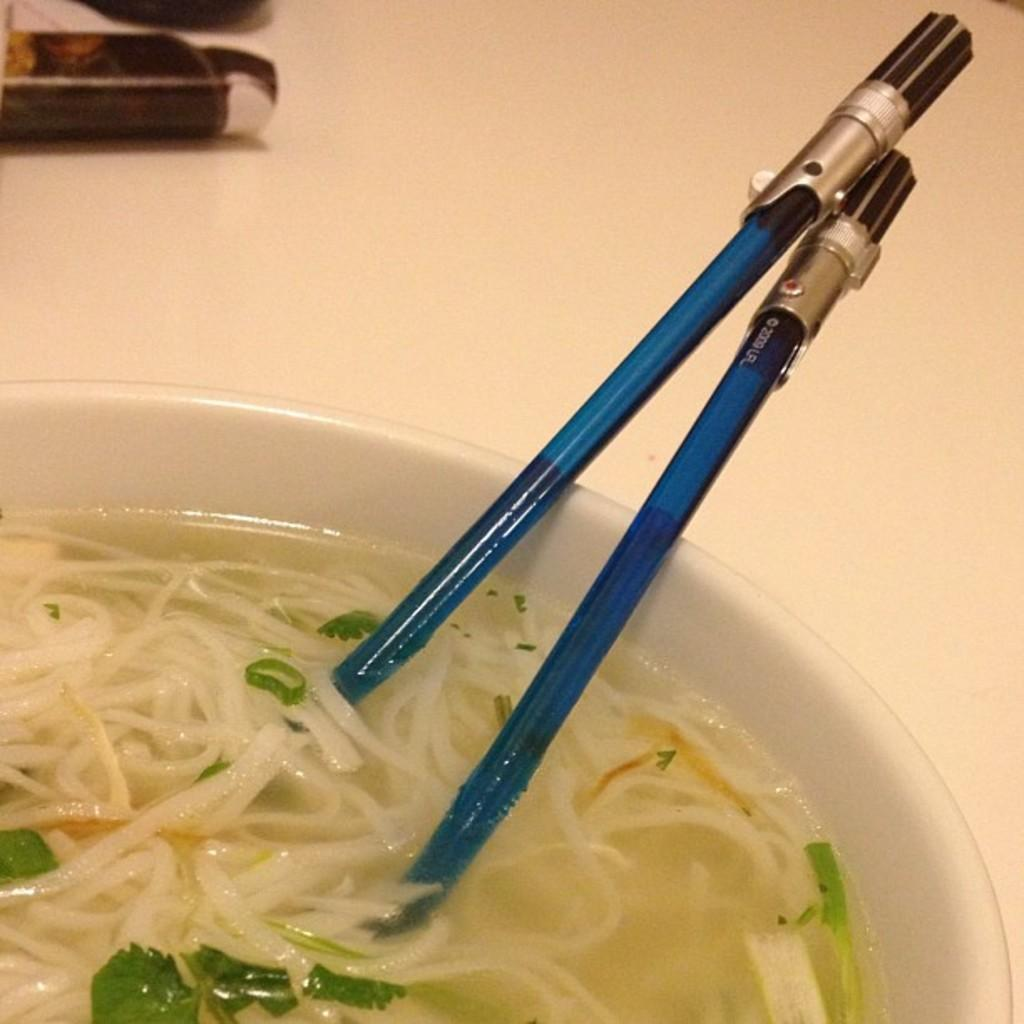What is inside the bowl that is visible in the image? There is food inside a bowl in the image. How many spoons are present in the image? There are two spoons in the image. What hobbies does the pump in the image enjoy? There is no pump present in the image, so it is not possible to determine its hobbies. 